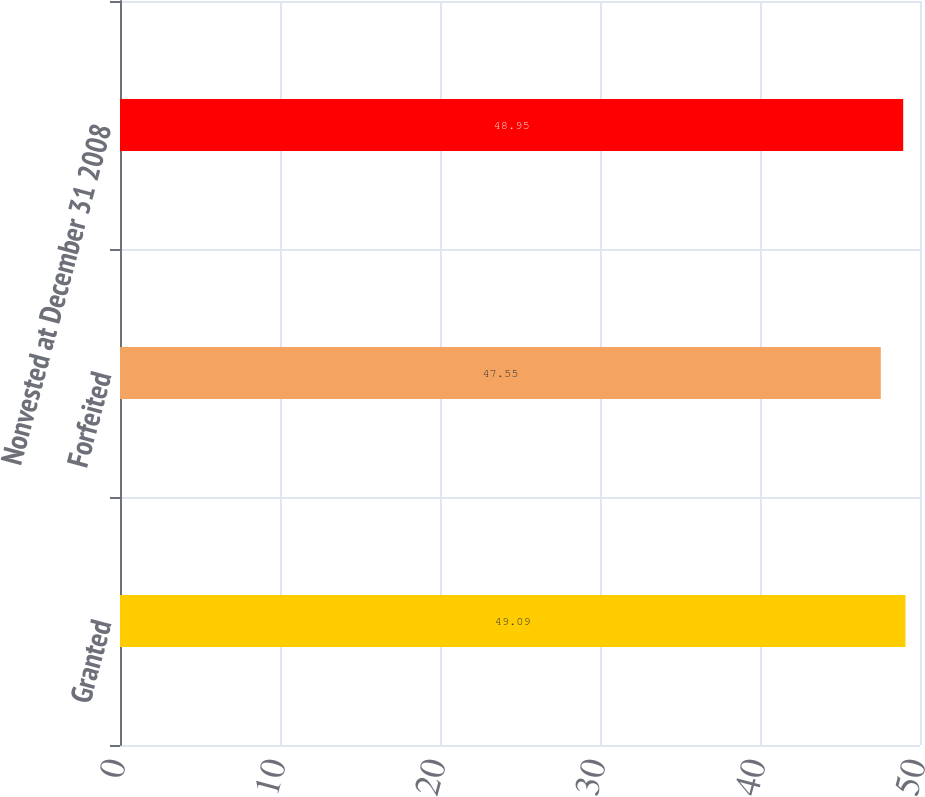<chart> <loc_0><loc_0><loc_500><loc_500><bar_chart><fcel>Granted<fcel>Forfeited<fcel>Nonvested at December 31 2008<nl><fcel>49.09<fcel>47.55<fcel>48.95<nl></chart> 